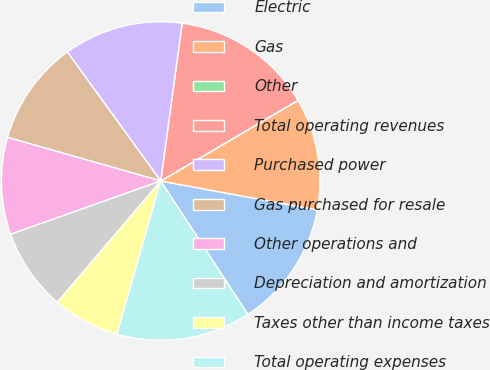Convert chart. <chart><loc_0><loc_0><loc_500><loc_500><pie_chart><fcel>Electric<fcel>Gas<fcel>Other<fcel>Total operating revenues<fcel>Purchased power<fcel>Gas purchased for resale<fcel>Other operations and<fcel>Depreciation and amortization<fcel>Taxes other than income taxes<fcel>Total operating expenses<nl><fcel>12.88%<fcel>11.36%<fcel>0.01%<fcel>14.39%<fcel>12.12%<fcel>10.61%<fcel>9.85%<fcel>8.33%<fcel>6.82%<fcel>13.63%<nl></chart> 